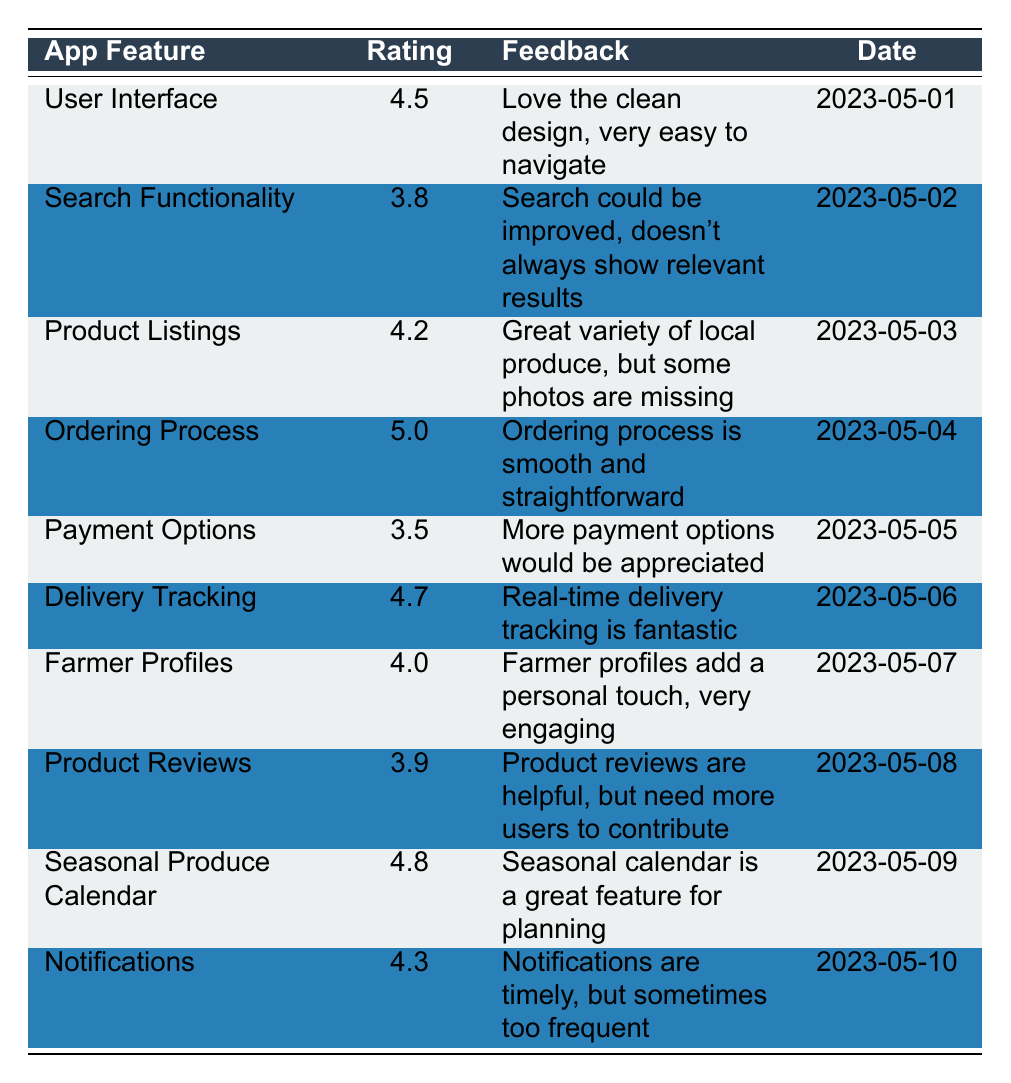What is the rating for the "Product Listings" feature? The rating for "Product Listings" is found in the table directly under the Ratings column next to the feature name. It shows 4.2
Answer: 4.2 Which app feature received the highest rating? The highest rating can be identified in the Ratings column by scanning for the largest number, which is 5.0 next to "Ordering Process."
Answer: Ordering Process What feedback did the user provide for the "Search Functionality" feature? The feedback provided is located in the table next to the "Search Functionality" rating, which notes that the search could be improved and doesn't always show relevant results.
Answer: Search could be improved, doesn't always show relevant results What is the average rating of all app features? To find the average, add all the ratings together (4.5 + 3.8 + 4.2 + 5.0 + 3.5 + 4.7 + 4.0 + 3.9 + 4.8 + 4.3 = 46.7) and divide by the number of features (10), resulting in an average of 46.7/10 = 4.67.
Answer: 4.67 Did any feature score below 4.0? By checking the Ratings column for ratings below 4.0, "Payment Options" with a rating of 3.5 is identified as below 4.0. Therefore, it is true that one feature scored below this threshold.
Answer: Yes Which feature received feedback suggesting that more user contributions are needed? "Product Reviews" has feedback stating that reviews are helpful but need more users to contribute, identified in the feedback column under "Product Reviews."
Answer: Product Reviews What are the ratings for features that received feedback mentioning user engagement? The features with feedback related to user engagement include "Farmer Profiles" (4.0) as it adds a personal touch and "Product Reviews" (3.9) as it indicates the need for more user contributions.
Answer: Farmer Profiles (4.0) and Product Reviews (3.9) What is the relationship between the "Delivery Tracking" feature and its rating? The "Delivery Tracking" feature is rated 4.7, which is noted in the table, and it is associated with positive feedback stating that real-time delivery tracking is fantastic, indicating user satisfaction with this feature.
Answer: Positive relationship with a rating of 4.7 